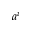Convert formula to latex. <formula><loc_0><loc_0><loc_500><loc_500>a ^ { i }</formula> 